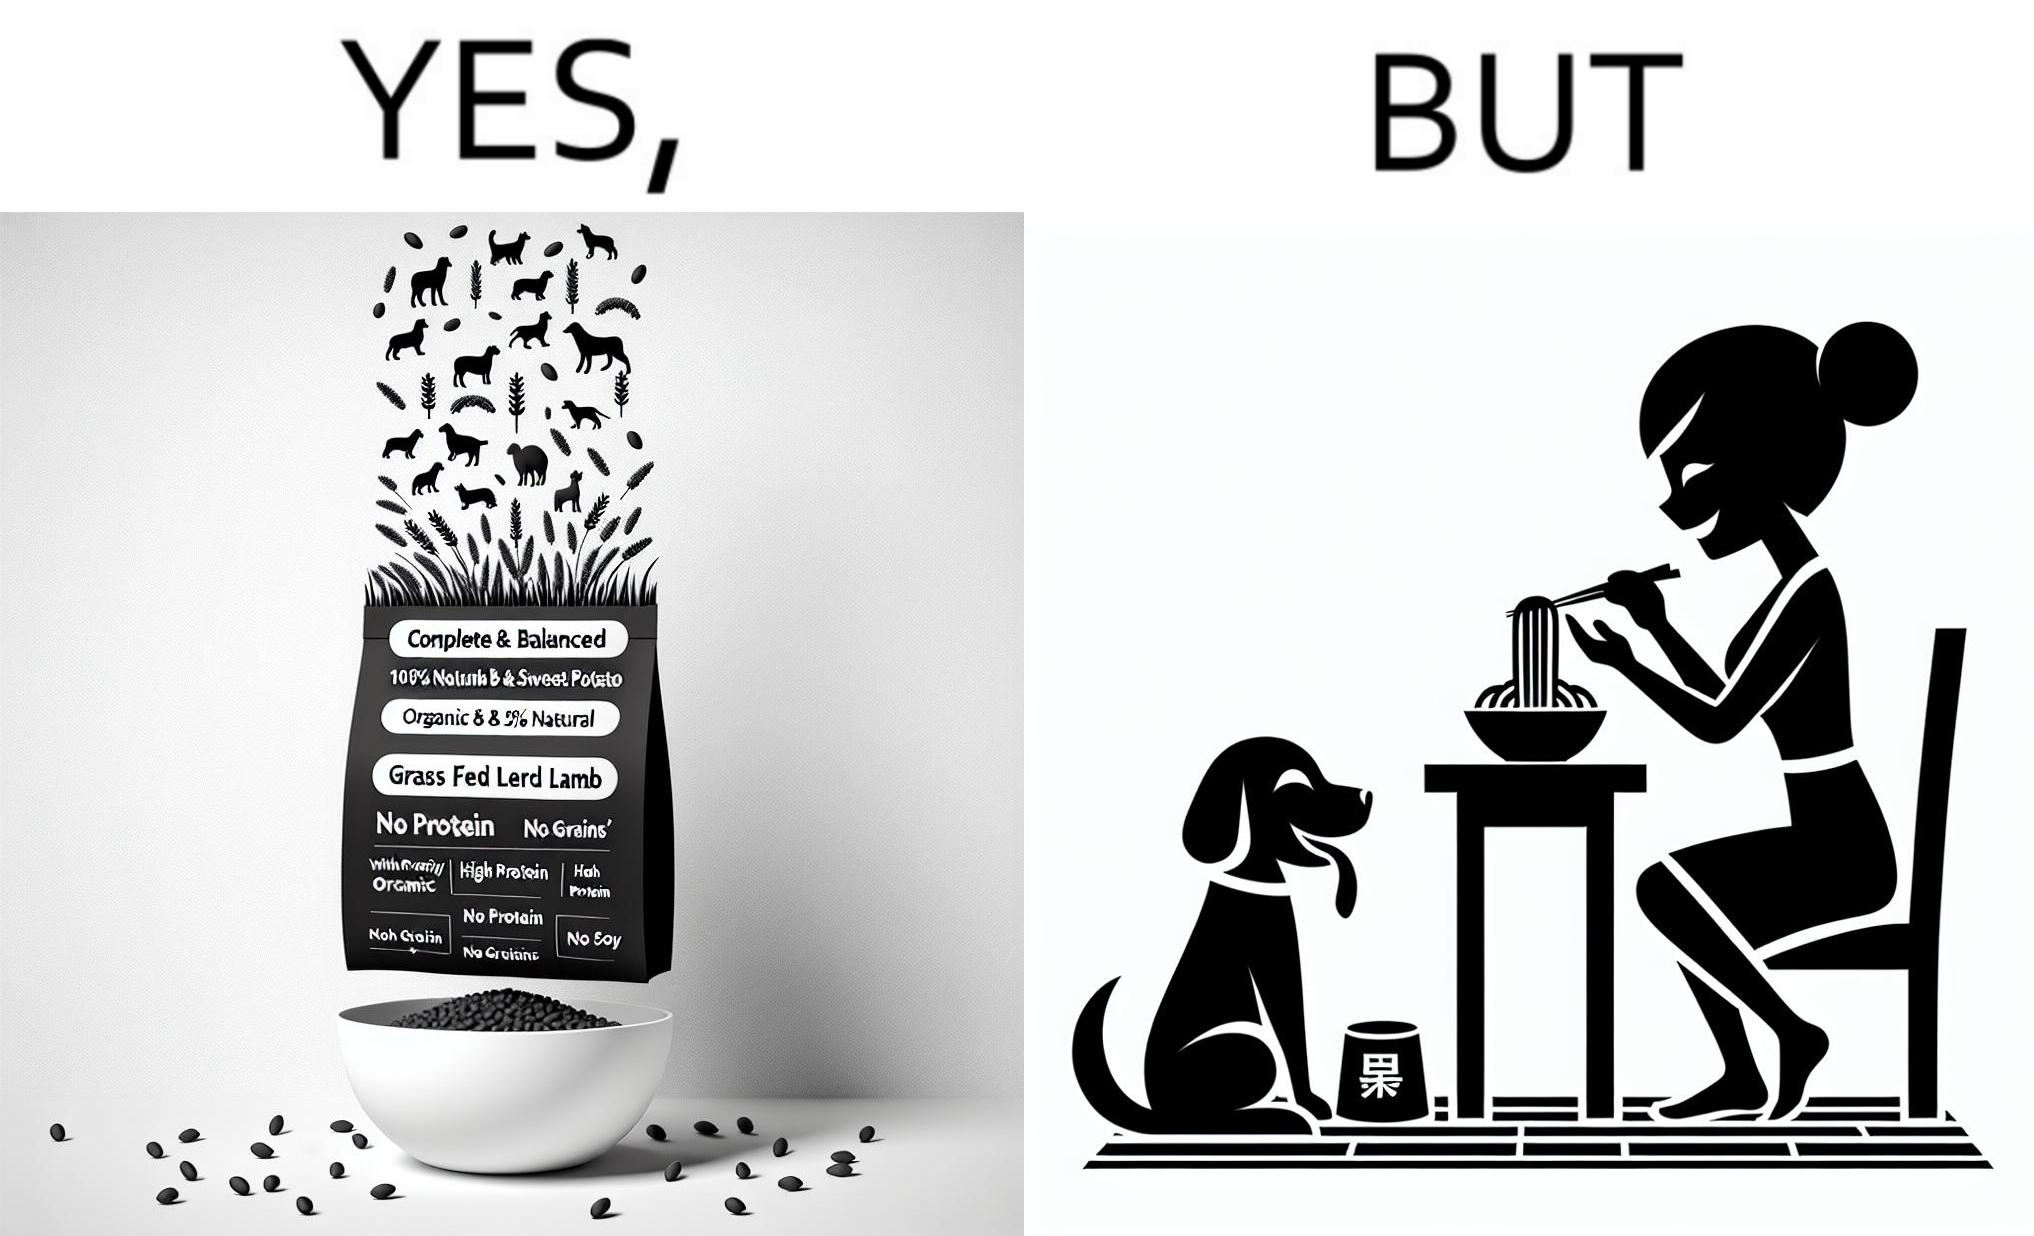Is this a satirical image? Yes, this image is satirical. 